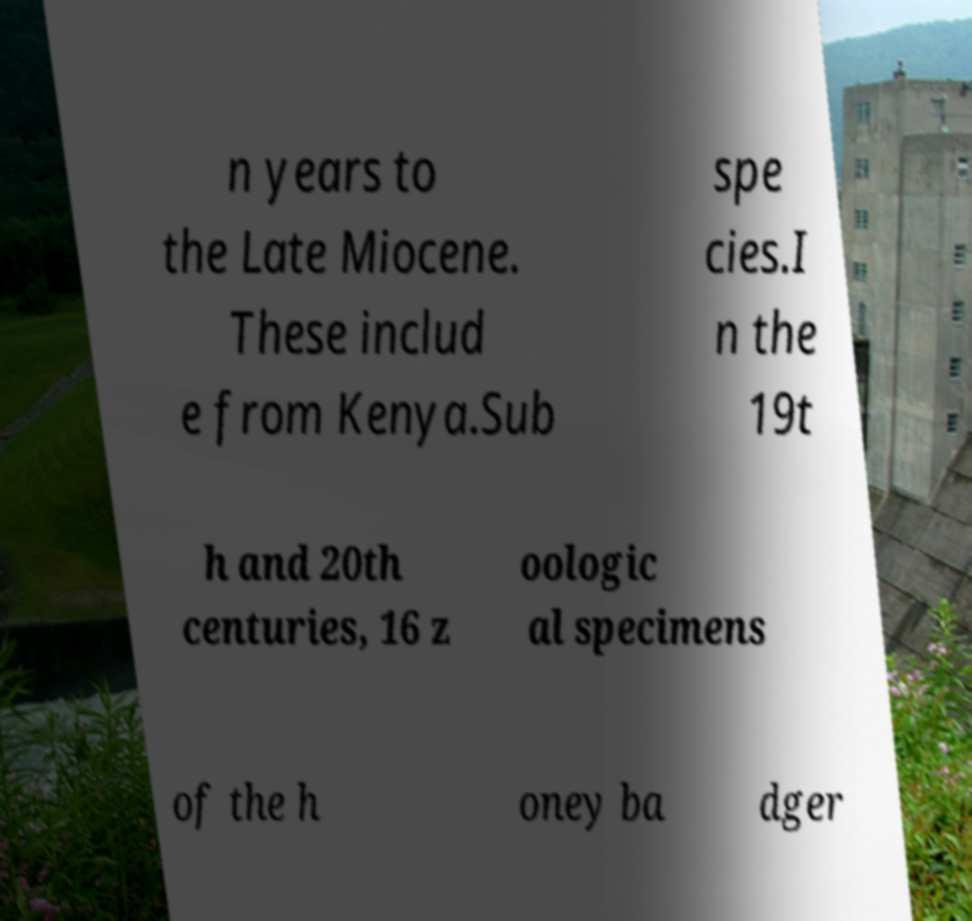Could you extract and type out the text from this image? n years to the Late Miocene. These includ e from Kenya.Sub spe cies.I n the 19t h and 20th centuries, 16 z oologic al specimens of the h oney ba dger 